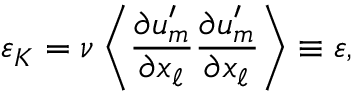Convert formula to latex. <formula><loc_0><loc_0><loc_500><loc_500>\varepsilon _ { K } = \nu \left \langle { \frac { \partial u _ { m } ^ { \prime } } { \partial x _ { \ell } } \frac { \partial u _ { m } ^ { \prime } } { \partial x _ { \ell } } } \right \rangle \equiv \varepsilon ,</formula> 